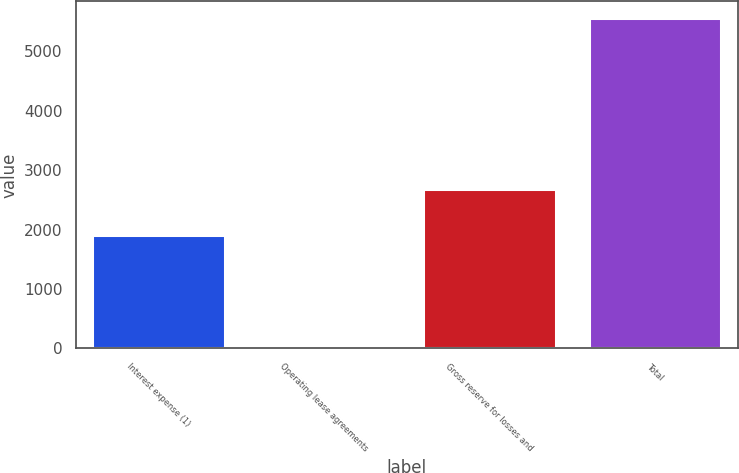Convert chart to OTSL. <chart><loc_0><loc_0><loc_500><loc_500><bar_chart><fcel>Interest expense (1)<fcel>Operating lease agreements<fcel>Gross reserve for losses and<fcel>Total<nl><fcel>1900.6<fcel>3.5<fcel>2678.1<fcel>5562<nl></chart> 